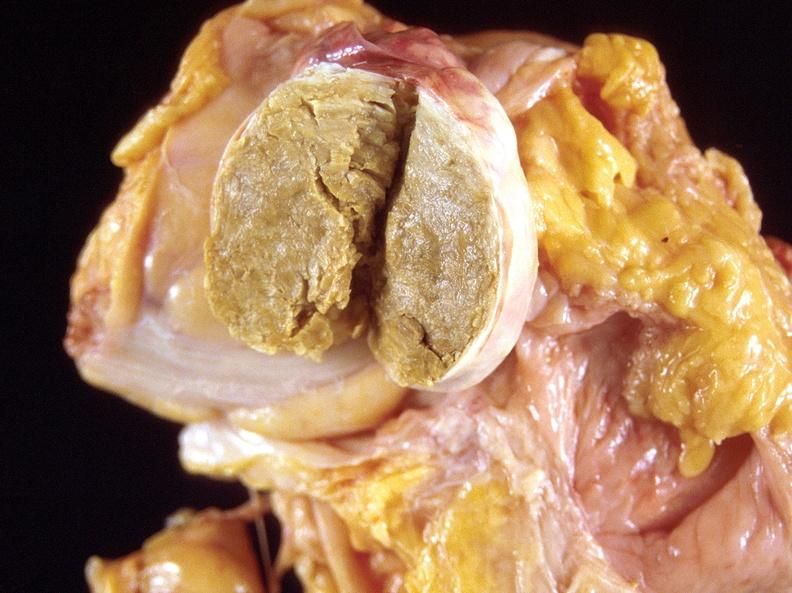does this image show dermoid cyst?
Answer the question using a single word or phrase. Yes 